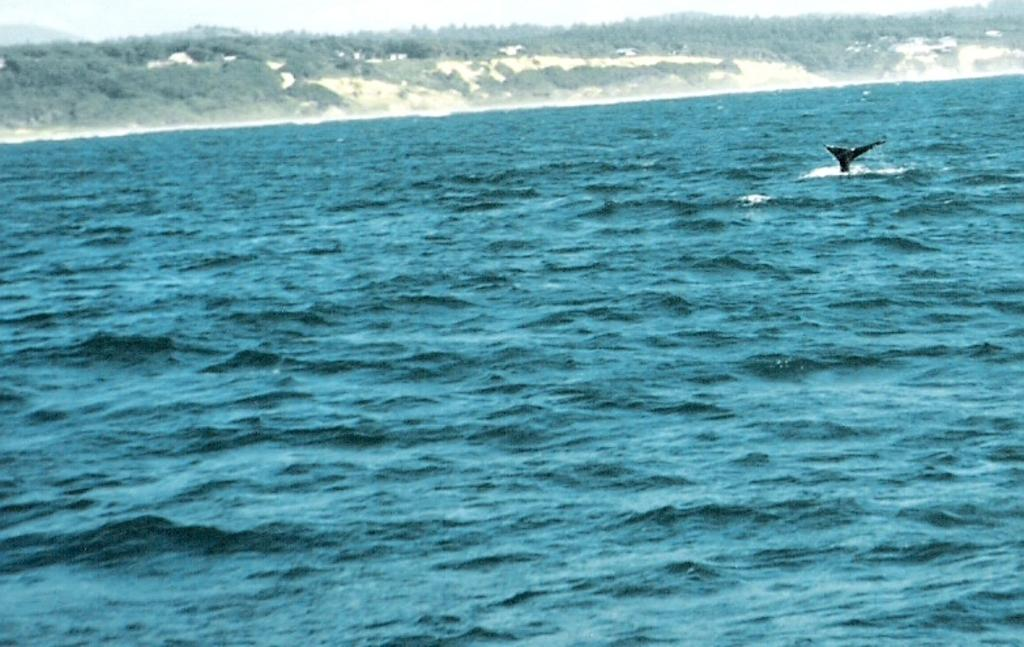What is visible in the image? Water is visible in the image. What can be seen in the background of the image? There are trees and a clear sky in the background of the image. How many nails can be seen in the image? There are no nails present in the image. What type of shop is visible in the image? There is no shop visible in the image. 